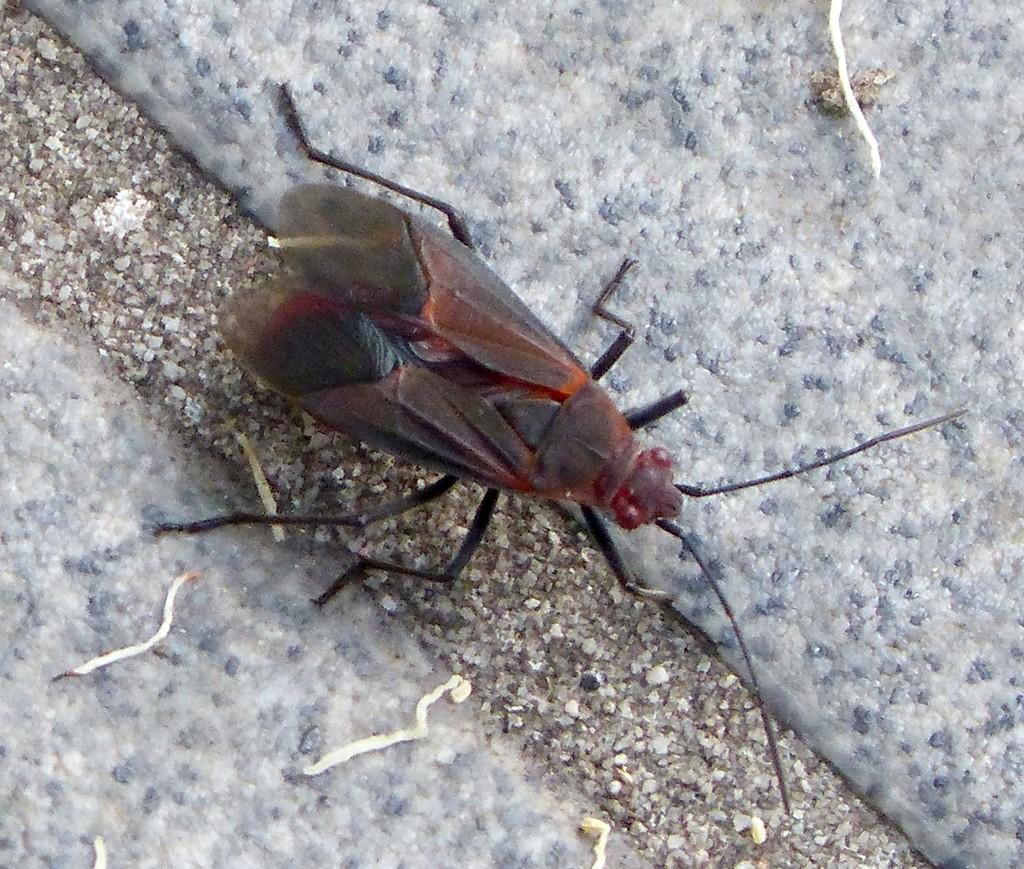What type of creature is in the image? There is an insect in the image. What colors can be seen on the insect? The insect has black, brown, red, and orange colors. What is the background or surface that the insect is on? The insect is on a cream and black colored surface. What color are the objects on the surface? There are white colored objects on the surface. Are there any spiders on the desk in the image? There is no mention of a desk or spiders in the image, so we cannot answer this question. What type of toys are present in the image? There is no mention of toys in the image, so we cannot answer this question. 